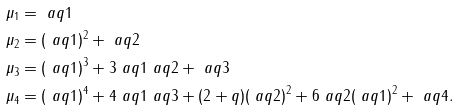<formula> <loc_0><loc_0><loc_500><loc_500>\mu _ { 1 } & = \ a q 1 \\ \mu _ { 2 } & = ( \ a q 1 ) ^ { 2 } + \ a q 2 \\ \mu _ { 3 } & = ( \ a q 1 ) ^ { 3 } + 3 \ a q 1 \ a q 2 + \ a q 3 \\ \mu _ { 4 } & = ( \ a q 1 ) ^ { 4 } + 4 \ a q 1 \ a q 3 + ( 2 + q ) ( \ a q 2 ) ^ { 2 } + 6 \ a q 2 ( \ a q 1 ) ^ { 2 } + \ a q 4 .</formula> 